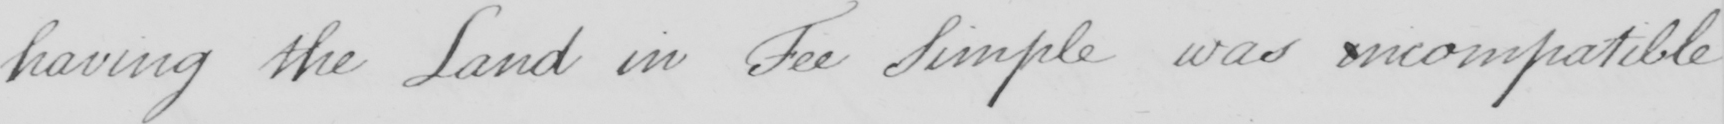Please provide the text content of this handwritten line. having the Land in Fee Simple was incompatible 